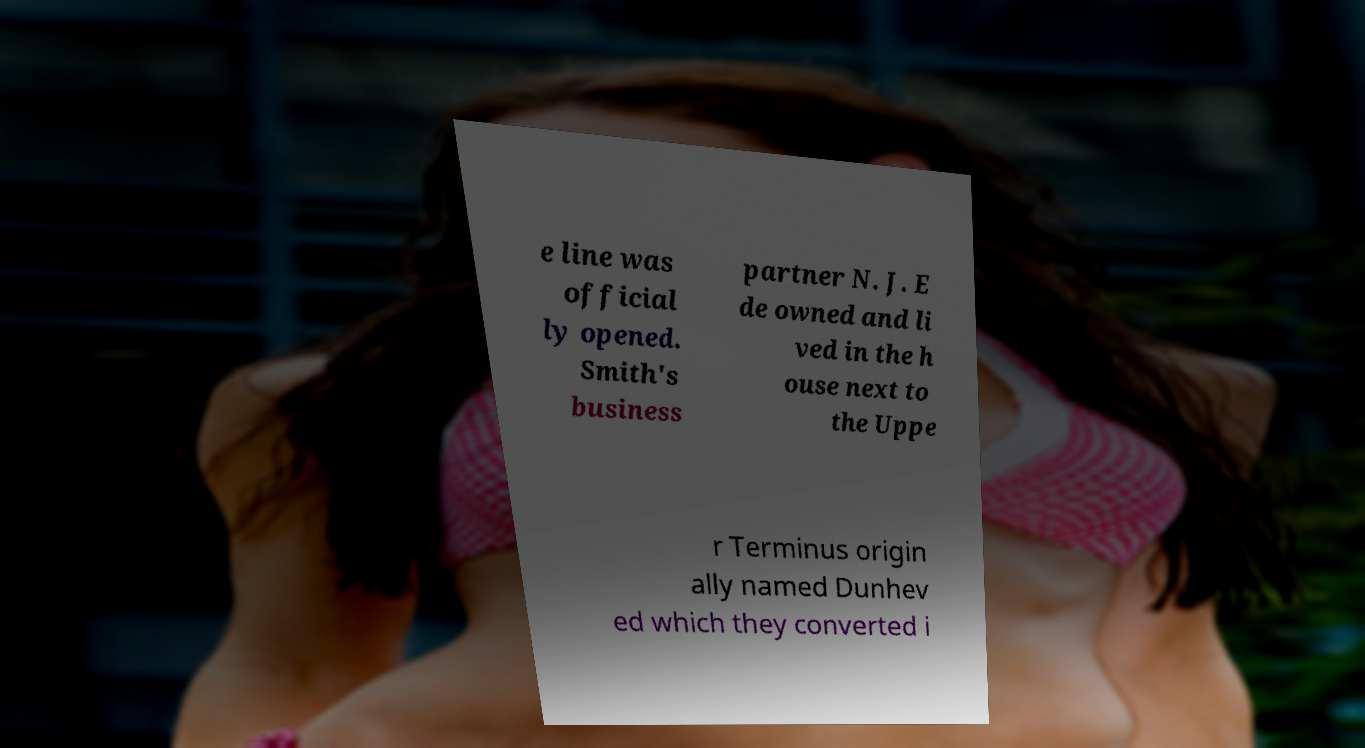Could you assist in decoding the text presented in this image and type it out clearly? e line was official ly opened. Smith's business partner N. J. E de owned and li ved in the h ouse next to the Uppe r Terminus origin ally named Dunhev ed which they converted i 